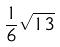Convert formula to latex. <formula><loc_0><loc_0><loc_500><loc_500>\frac { 1 } { 6 } \sqrt { 1 3 }</formula> 